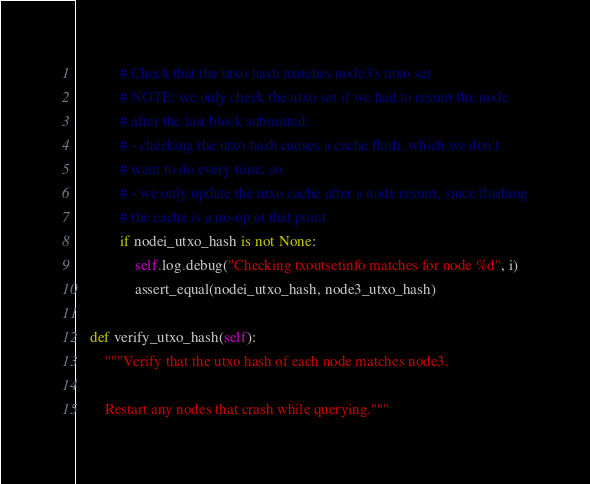<code> <loc_0><loc_0><loc_500><loc_500><_Python_>
            # Check that the utxo hash matches node3's utxo set
            # NOTE: we only check the utxo set if we had to restart the node
            # after the last block submitted:
            # - checking the utxo hash causes a cache flush, which we don't
            # want to do every time; so
            # - we only update the utxo cache after a node restart, since flushing
            # the cache is a no-op at that point
            if nodei_utxo_hash is not None:
                self.log.debug("Checking txoutsetinfo matches for node %d", i)
                assert_equal(nodei_utxo_hash, node3_utxo_hash)

    def verify_utxo_hash(self):
        """Verify that the utxo hash of each node matches node3.

        Restart any nodes that crash while querying."""</code> 